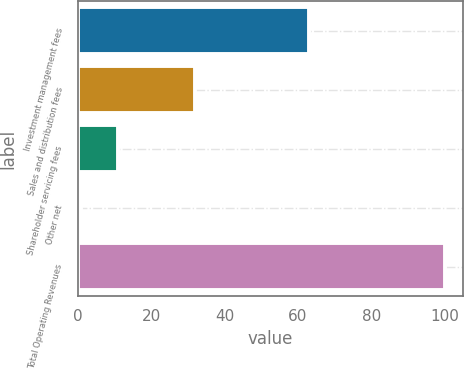Convert chart to OTSL. <chart><loc_0><loc_0><loc_500><loc_500><bar_chart><fcel>Investment management fees<fcel>Sales and distribution fees<fcel>Shareholder servicing fees<fcel>Other net<fcel>Total Operating Revenues<nl><fcel>63<fcel>32<fcel>10.9<fcel>1<fcel>100<nl></chart> 